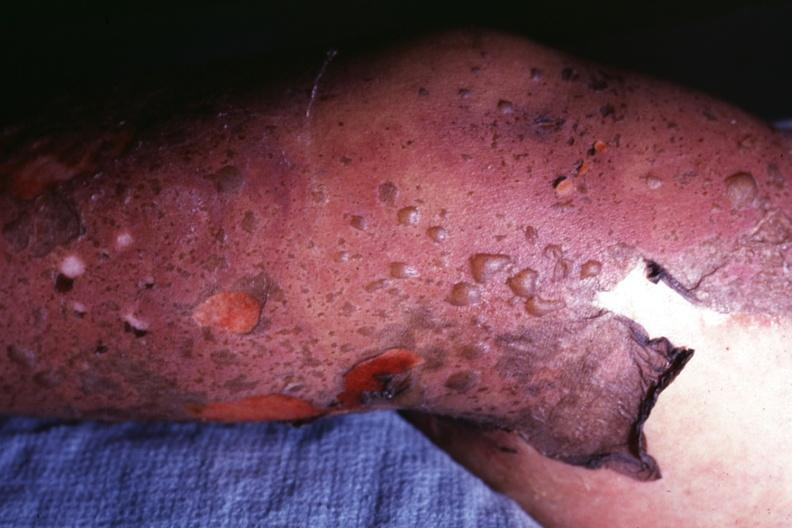how is this what it looks like?
Answer the question using a single word or phrase. Sure 